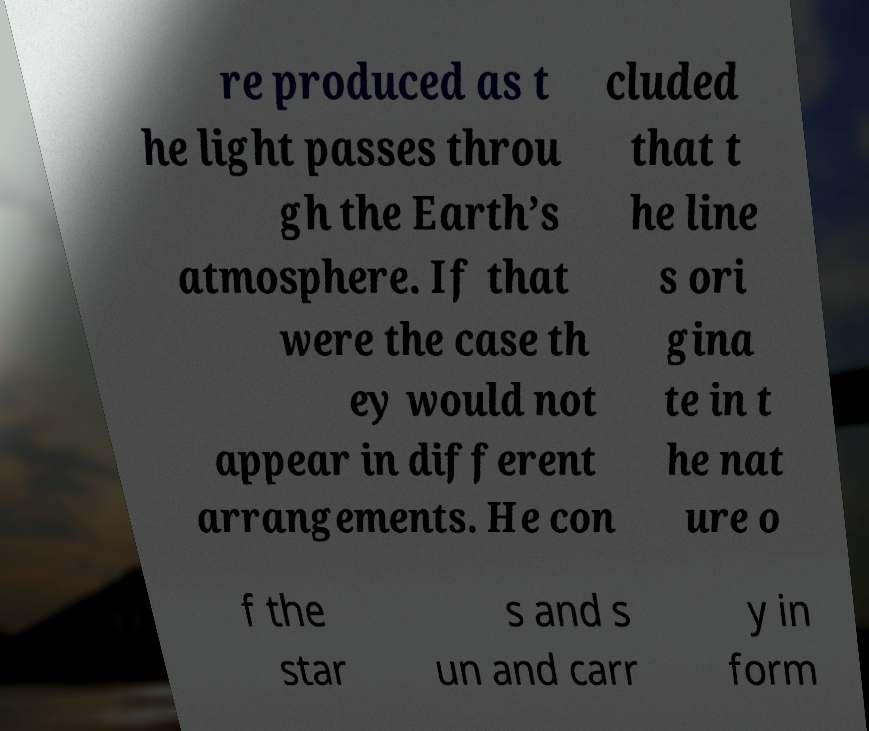What messages or text are displayed in this image? I need them in a readable, typed format. re produced as t he light passes throu gh the Earth’s atmosphere. If that were the case th ey would not appear in different arrangements. He con cluded that t he line s ori gina te in t he nat ure o f the star s and s un and carr y in form 